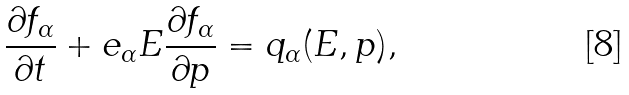Convert formula to latex. <formula><loc_0><loc_0><loc_500><loc_500>\frac { \partial f _ { \alpha } } { \partial t } + e _ { \alpha } E \frac { \partial f _ { \alpha } } { \partial p } = q _ { \alpha } ( E , p ) ,</formula> 